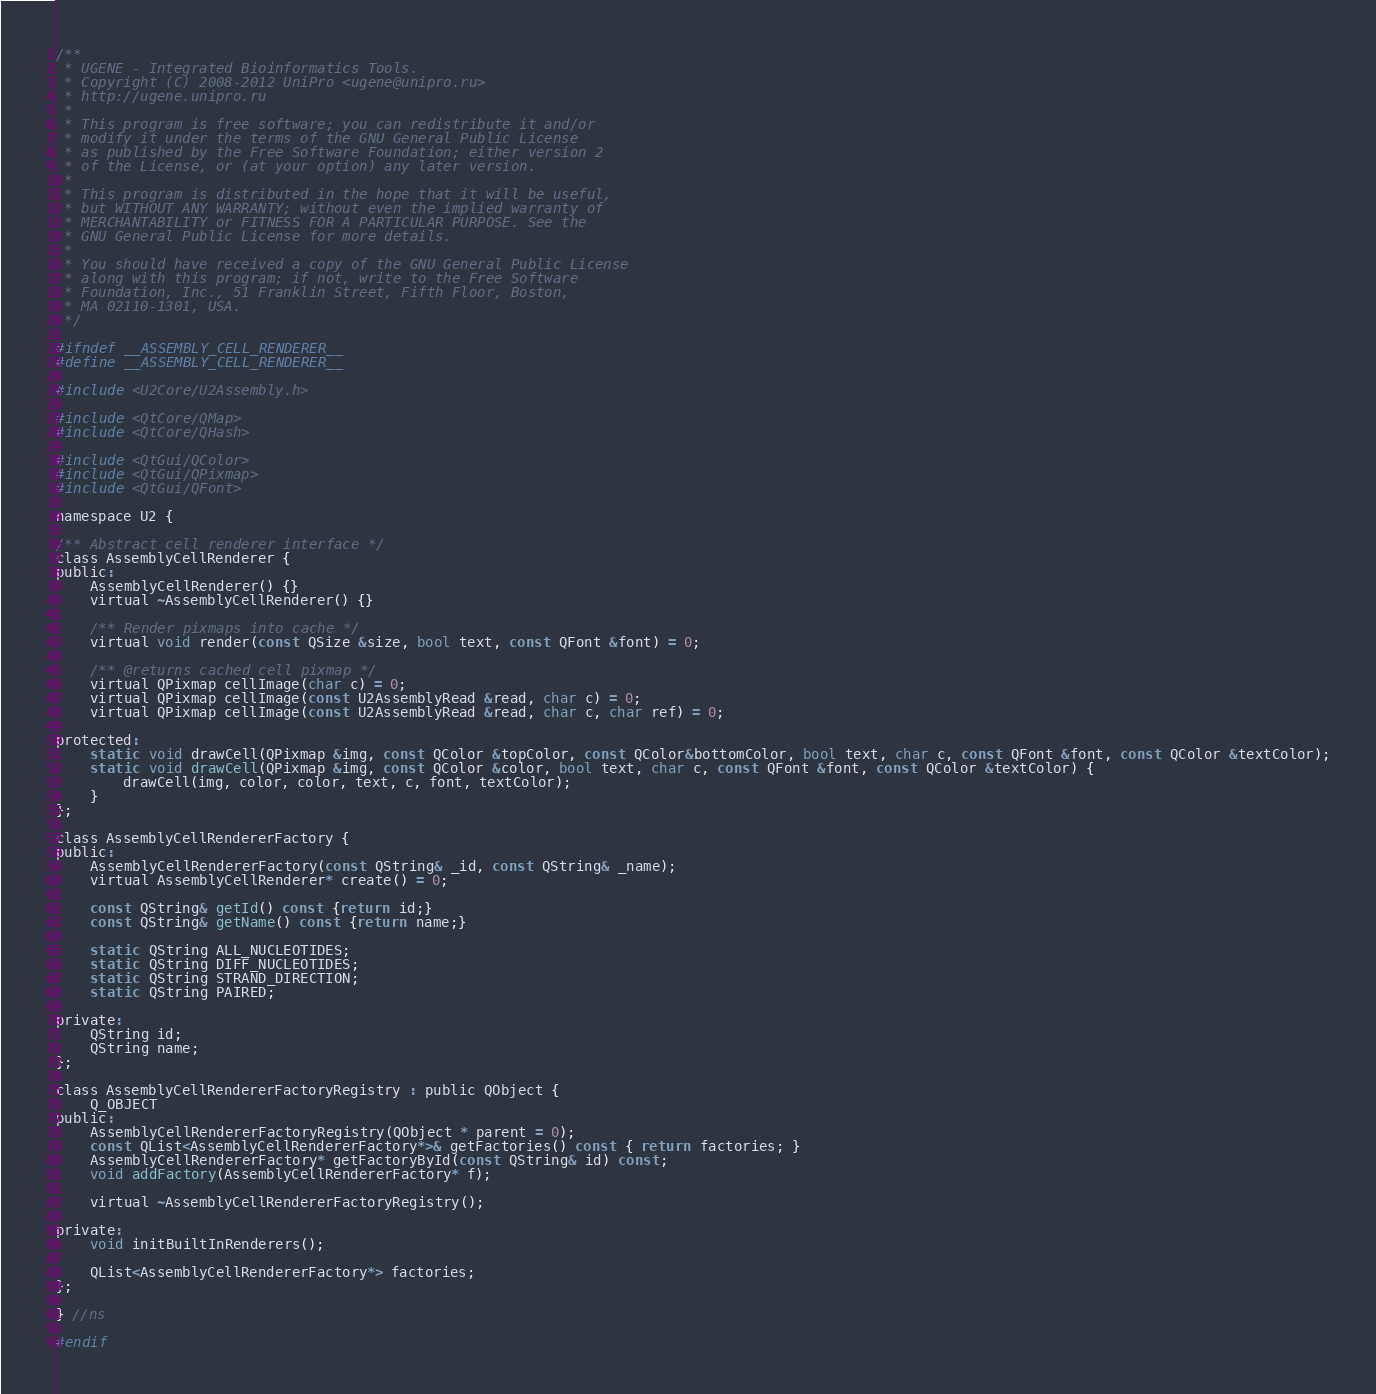Convert code to text. <code><loc_0><loc_0><loc_500><loc_500><_C_>/**
 * UGENE - Integrated Bioinformatics Tools.
 * Copyright (C) 2008-2012 UniPro <ugene@unipro.ru>
 * http://ugene.unipro.ru
 *
 * This program is free software; you can redistribute it and/or
 * modify it under the terms of the GNU General Public License
 * as published by the Free Software Foundation; either version 2
 * of the License, or (at your option) any later version.
 *
 * This program is distributed in the hope that it will be useful,
 * but WITHOUT ANY WARRANTY; without even the implied warranty of
 * MERCHANTABILITY or FITNESS FOR A PARTICULAR PURPOSE. See the
 * GNU General Public License for more details.
 *
 * You should have received a copy of the GNU General Public License
 * along with this program; if not, write to the Free Software
 * Foundation, Inc., 51 Franklin Street, Fifth Floor, Boston,
 * MA 02110-1301, USA.
 */

#ifndef __ASSEMBLY_CELL_RENDERER__
#define __ASSEMBLY_CELL_RENDERER__

#include <U2Core/U2Assembly.h>

#include <QtCore/QMap>
#include <QtCore/QHash>

#include <QtGui/QColor>
#include <QtGui/QPixmap>
#include <QtGui/QFont>

namespace U2 {

/** Abstract cell renderer interface */
class AssemblyCellRenderer {
public:
    AssemblyCellRenderer() {}
    virtual ~AssemblyCellRenderer() {}

    /** Render pixmaps into cache */
    virtual void render(const QSize &size, bool text, const QFont &font) = 0;

    /** @returns cached cell pixmap */
    virtual QPixmap cellImage(char c) = 0;
    virtual QPixmap cellImage(const U2AssemblyRead &read, char c) = 0;
    virtual QPixmap cellImage(const U2AssemblyRead &read, char c, char ref) = 0;

protected:
    static void drawCell(QPixmap &img, const QColor &topColor, const QColor&bottomColor, bool text, char c, const QFont &font, const QColor &textColor);
    static void drawCell(QPixmap &img, const QColor &color, bool text, char c, const QFont &font, const QColor &textColor) {
        drawCell(img, color, color, text, c, font, textColor);
    }
};

class AssemblyCellRendererFactory {
public:
    AssemblyCellRendererFactory(const QString& _id, const QString& _name);
    virtual AssemblyCellRenderer* create() = 0;

    const QString& getId() const {return id;}
    const QString& getName() const {return name;}

    static QString ALL_NUCLEOTIDES;
    static QString DIFF_NUCLEOTIDES;
    static QString STRAND_DIRECTION;
    static QString PAIRED;

private:
    QString id;
    QString name;
};

class AssemblyCellRendererFactoryRegistry : public QObject {
    Q_OBJECT
public:
    AssemblyCellRendererFactoryRegistry(QObject * parent = 0);
    const QList<AssemblyCellRendererFactory*>& getFactories() const { return factories; }
    AssemblyCellRendererFactory* getFactoryById(const QString& id) const;
    void addFactory(AssemblyCellRendererFactory* f);

    virtual ~AssemblyCellRendererFactoryRegistry();

private:
    void initBuiltInRenderers();

    QList<AssemblyCellRendererFactory*> factories;
};

} //ns

#endif
</code> 